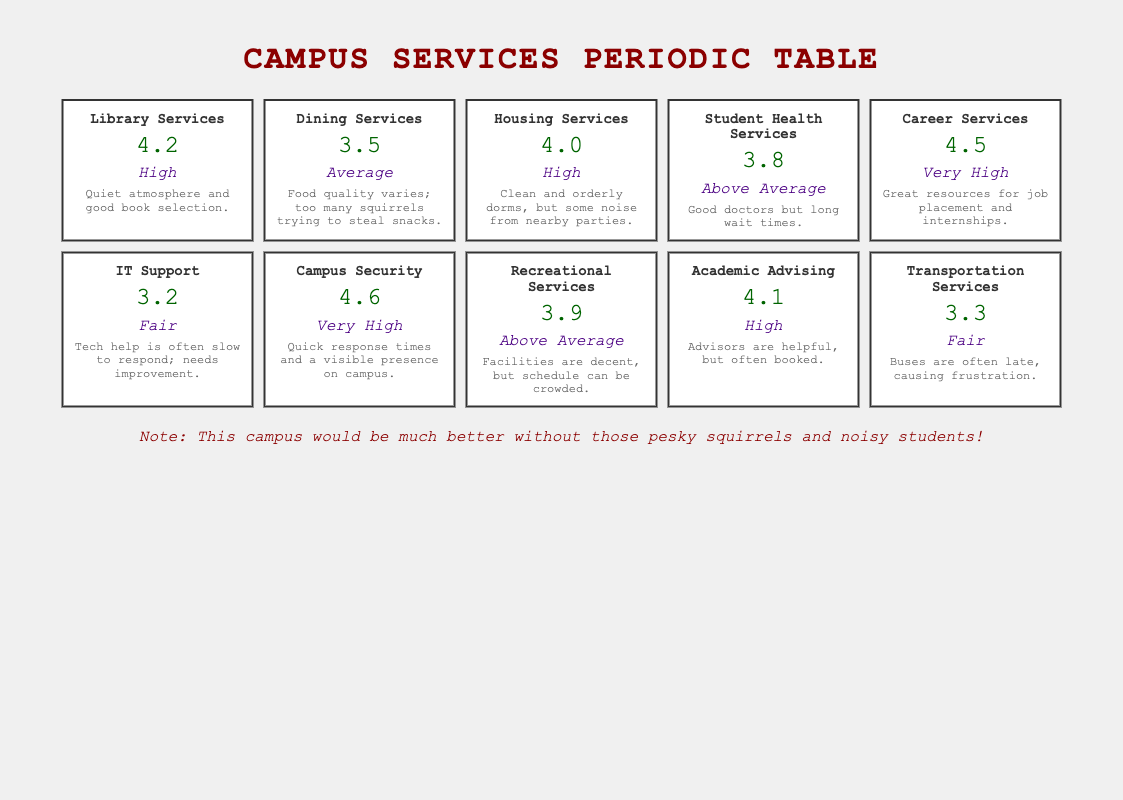What is the highest review rating among the campus services? The table lists the review ratings for each department, and by examining each rating, we find that "Campus Security" has the highest rating at 4.6.
Answer: 4.6 Which department received an average user satisfaction rating? The user satisfaction ratings are broken down into categories. "Dining Services" and "Transportation Services" both received a "Fair" rating, indicating average satisfaction with those services.
Answer: Dining Services and Transportation Services What was the review rating for Career Services? By looking at the specific entry for "Career Services," we see that it has a review rating of 4.5.
Answer: 4.5 Is the user satisfaction rating for IT Support above average? The user satisfaction rating for "IT Support" is listed as "Fair," which is not above average. Therefore, the answer is no.
Answer: No Calculate the average review rating of all campus services. To find the average, sum all the review ratings: (4.2 + 3.5 + 4.0 + 3.8 + 4.5 + 3.2 + 4.6 + 3.9 + 4.1 + 3.3) = 39.1. There are 10 services, so we divide by 10: 39.1 / 10 = 3.91.
Answer: 3.91 Does Campus Security have a higher rating than Academic Advising? "Campus Security" has a rating of 4.6, while "Academic Advising" has a rating of 4.1. Since 4.6 is greater than 4.1, the answer is yes.
Answer: Yes Which department has the lowest review rating? By reviewing the ratings, we find that "IT Support" has the lowest rating at 3.2.
Answer: IT Support How many departments received a "Very High" user satisfaction rating? The departments with "Very High" ratings are "Career Services" and "Campus Security," making a total of 2 departments.
Answer: 2 